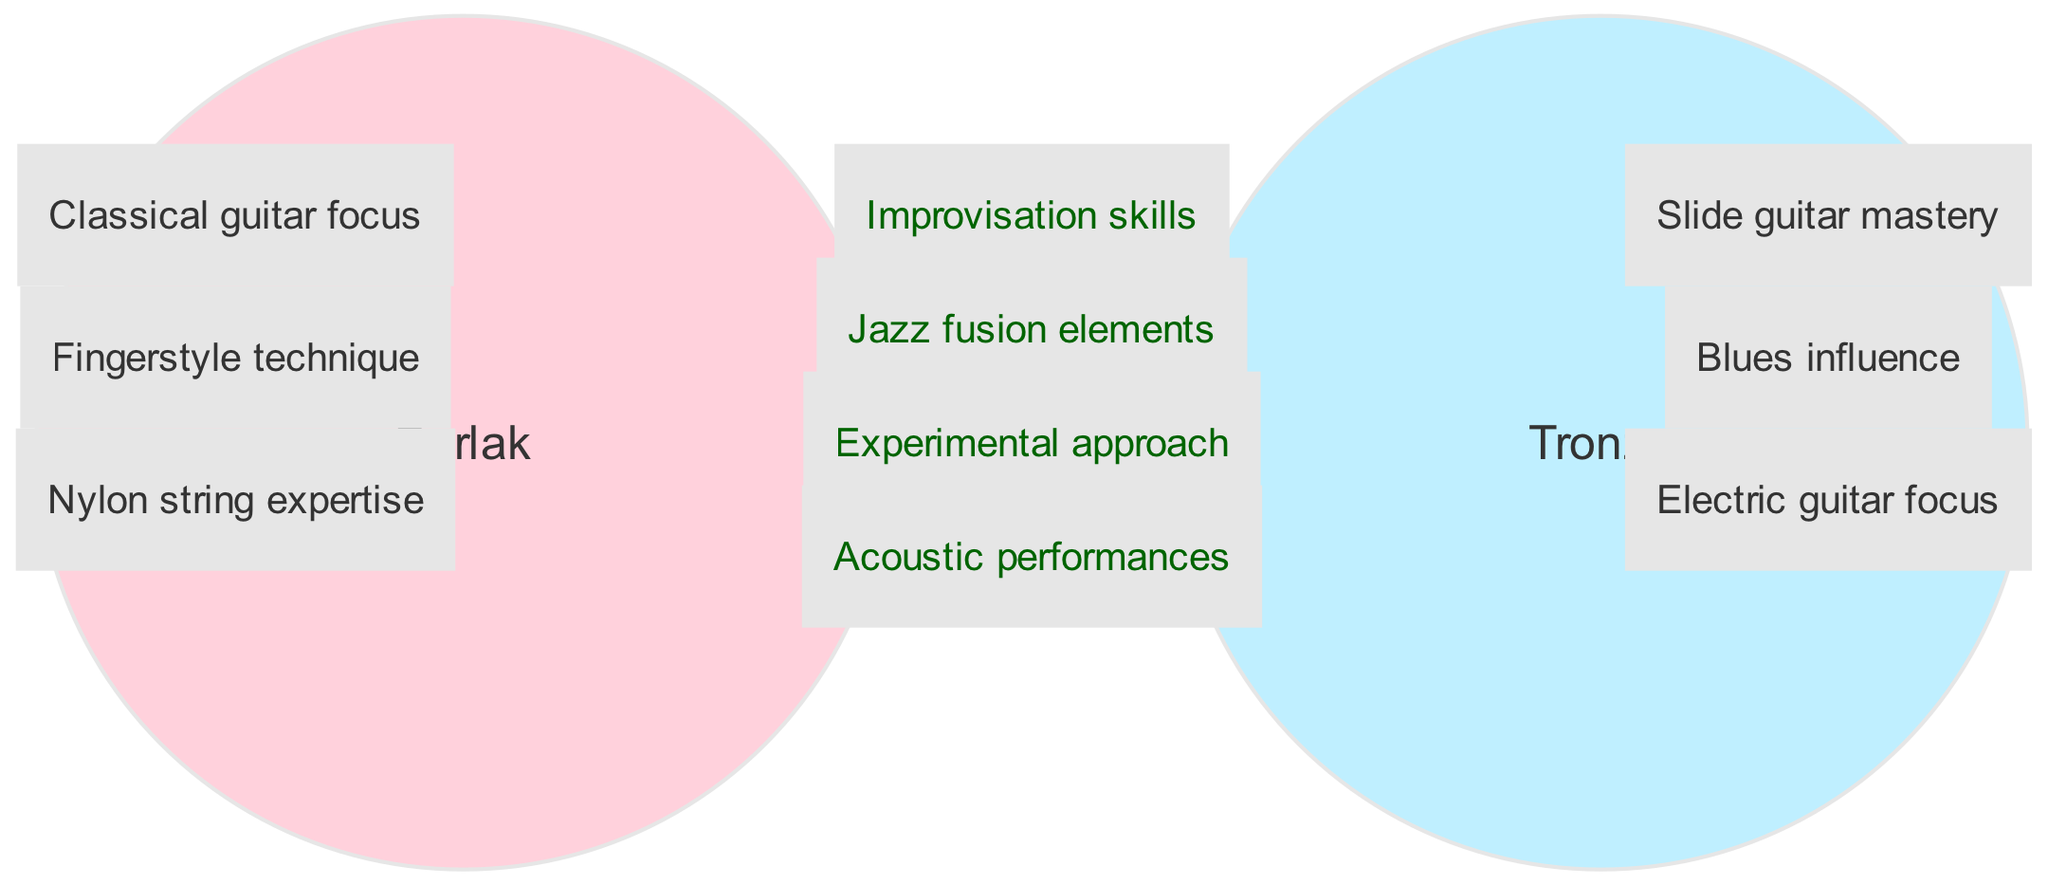What unique technique is associated with Perlak? The diagram indicates "Fingerstyle technique" as one of Perlak's unique elements. This is found in the section dedicated to Perlak's musical styles.
Answer: Fingerstyle technique What element reflects both musicians' styles? The intersection of the Venn diagram shows "Improvisation skills" as a shared element between Perlak and Tronzo, indicating a commonality in their approaches.
Answer: Improvisation skills How many unique elements are listed for Tronzo? Counting the elements in the Tronzo circle of the diagram shows three unique elements: "Slide guitar mastery," "Blues influence," and "Electric guitar focus."
Answer: 3 What is the main string type expertise of Perlak? Within the Perlak circle, the unique element "Nylon string expertise" reveals that Perlak specifically focuses on nylon strings in his musical technique.
Answer: Nylon string expertise Which musical influence is exclusive to Tronzo? The unique element "Blues influence" in the Tronzo circle signifies that this specific influence is exclusive and not shared with Perlak.
Answer: Blues influence How many elements are in the intersection of both musicians? By examining the intersection, we see there are four elements listed: "Improvisation skills," "Jazz fusion elements," "Experimental approach," and "Acoustic performances." This leads to the conclusion of four shared elements.
Answer: 4 What describes the general style shared by both musicians? The shared elements, specifically "Jazz fusion elements," indicate that both musicians incorporate influences from jazz fusion in their styles.
Answer: Jazz fusion elements What type of guitar focus is primarily associated with Tronzo? The diagram specifies "Electric guitar focus" as a unique element for Tronzo, indicating his primary association with electric guitar performance.
Answer: Electric guitar focus What performance style do both musicians employ? The intersection lists "Acoustic performances," indicating that both Perlak and Tronzo include acoustic performances within their musical repertoires.
Answer: Acoustic performances 